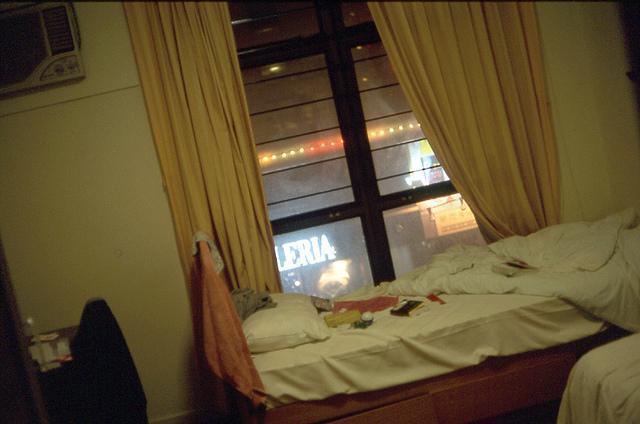The last four letters seen in the background are all found in what word?
Pick the correct solution from the four options below to address the question.
Options: Pizzeria, loquacious, quash, sublime. Pizzeria. 